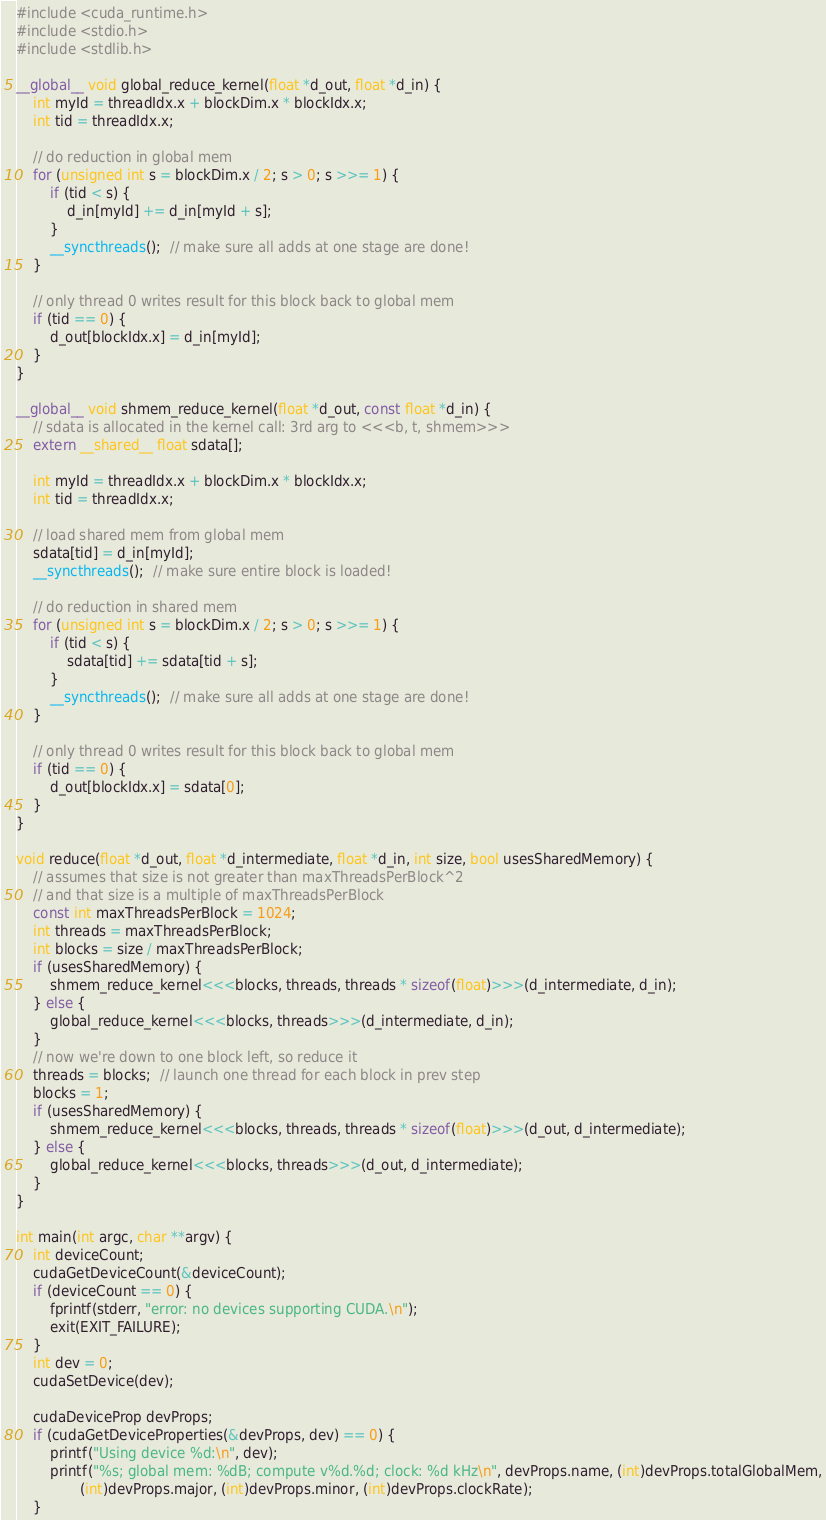Convert code to text. <code><loc_0><loc_0><loc_500><loc_500><_Cuda_>#include <cuda_runtime.h>
#include <stdio.h>
#include <stdlib.h>

__global__ void global_reduce_kernel(float *d_out, float *d_in) {
    int myId = threadIdx.x + blockDim.x * blockIdx.x;
    int tid = threadIdx.x;

    // do reduction in global mem
    for (unsigned int s = blockDim.x / 2; s > 0; s >>= 1) {
        if (tid < s) {
            d_in[myId] += d_in[myId + s];
        }
        __syncthreads();  // make sure all adds at one stage are done!
    }

    // only thread 0 writes result for this block back to global mem
    if (tid == 0) {
        d_out[blockIdx.x] = d_in[myId];
    }
}

__global__ void shmem_reduce_kernel(float *d_out, const float *d_in) {
    // sdata is allocated in the kernel call: 3rd arg to <<<b, t, shmem>>>
    extern __shared__ float sdata[];

    int myId = threadIdx.x + blockDim.x * blockIdx.x;
    int tid = threadIdx.x;

    // load shared mem from global mem
    sdata[tid] = d_in[myId];
    __syncthreads();  // make sure entire block is loaded!

    // do reduction in shared mem
    for (unsigned int s = blockDim.x / 2; s > 0; s >>= 1) {
        if (tid < s) {
            sdata[tid] += sdata[tid + s];
        }
        __syncthreads();  // make sure all adds at one stage are done!
    }

    // only thread 0 writes result for this block back to global mem
    if (tid == 0) {
        d_out[blockIdx.x] = sdata[0];
    }
}

void reduce(float *d_out, float *d_intermediate, float *d_in, int size, bool usesSharedMemory) {
    // assumes that size is not greater than maxThreadsPerBlock^2
    // and that size is a multiple of maxThreadsPerBlock
    const int maxThreadsPerBlock = 1024;
    int threads = maxThreadsPerBlock;
    int blocks = size / maxThreadsPerBlock;
    if (usesSharedMemory) {
        shmem_reduce_kernel<<<blocks, threads, threads * sizeof(float)>>>(d_intermediate, d_in);
    } else {
        global_reduce_kernel<<<blocks, threads>>>(d_intermediate, d_in);
    }
    // now we're down to one block left, so reduce it
    threads = blocks;  // launch one thread for each block in prev step
    blocks = 1;
    if (usesSharedMemory) {
        shmem_reduce_kernel<<<blocks, threads, threads * sizeof(float)>>>(d_out, d_intermediate);
    } else {
        global_reduce_kernel<<<blocks, threads>>>(d_out, d_intermediate);
    }
}

int main(int argc, char **argv) {
    int deviceCount;
    cudaGetDeviceCount(&deviceCount);
    if (deviceCount == 0) {
        fprintf(stderr, "error: no devices supporting CUDA.\n");
        exit(EXIT_FAILURE);
    }
    int dev = 0;
    cudaSetDevice(dev);

    cudaDeviceProp devProps;
    if (cudaGetDeviceProperties(&devProps, dev) == 0) {
        printf("Using device %d:\n", dev);
        printf("%s; global mem: %dB; compute v%d.%d; clock: %d kHz\n", devProps.name, (int)devProps.totalGlobalMem,
               (int)devProps.major, (int)devProps.minor, (int)devProps.clockRate);
    }
</code> 